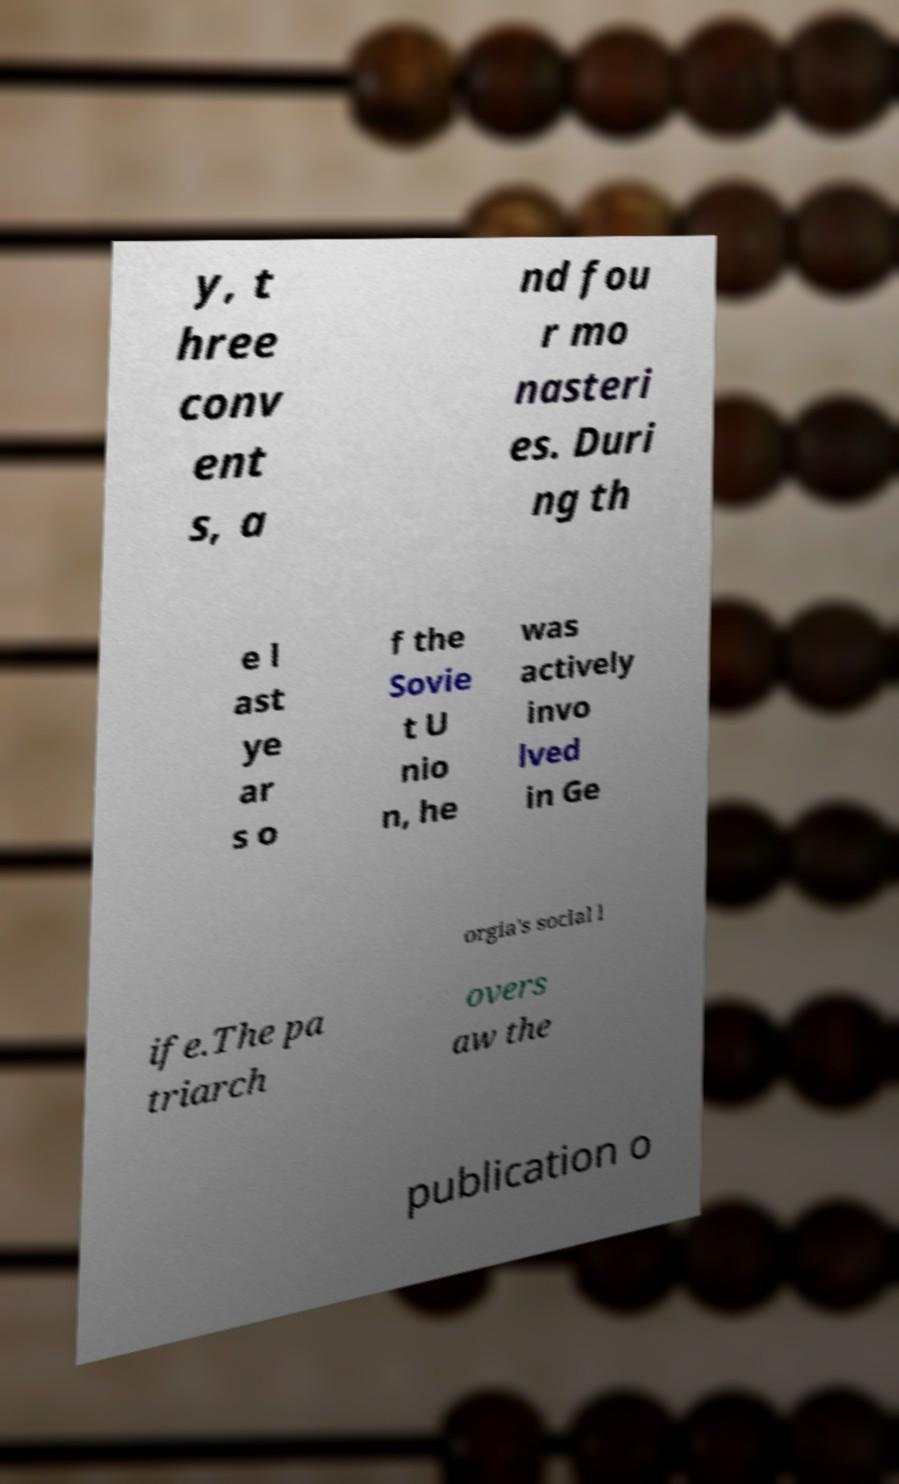I need the written content from this picture converted into text. Can you do that? y, t hree conv ent s, a nd fou r mo nasteri es. Duri ng th e l ast ye ar s o f the Sovie t U nio n, he was actively invo lved in Ge orgia's social l ife.The pa triarch overs aw the publication o 